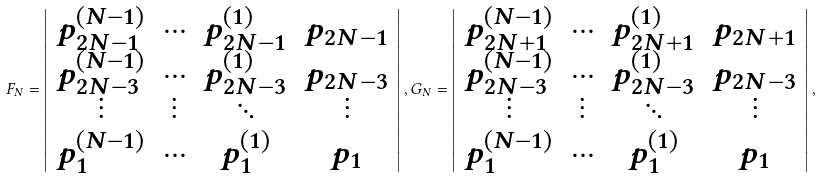Convert formula to latex. <formula><loc_0><loc_0><loc_500><loc_500>F _ { N } = \left | \begin{array} { c c c c } p _ { 2 N - 1 } ^ { ( N - 1 ) } & \cdots & p _ { 2 N - 1 } ^ { ( 1 ) } & p _ { 2 N - 1 } \\ p _ { 2 N - 3 } ^ { ( N - 1 ) } & \cdots & p _ { 2 N - 3 } ^ { ( 1 ) } & p _ { 2 N - 3 } \\ \vdots & \vdots & \ddots & \vdots \\ p _ { 1 } ^ { ( N - 1 ) } & \cdots & p _ { 1 } ^ { ( 1 ) } & p _ { 1 } \end{array} \right | , G _ { N } = \left | \begin{array} { c c c c } p _ { 2 N + 1 } ^ { ( N - 1 ) } & \cdots & p _ { 2 N + 1 } ^ { ( 1 ) } & p _ { 2 N + 1 } \\ p _ { 2 N - 3 } ^ { ( N - 1 ) } & \cdots & p _ { 2 N - 3 } ^ { ( 1 ) } & p _ { 2 N - 3 } \\ \vdots & \vdots & \ddots & \vdots \\ p _ { 1 } ^ { ( N - 1 ) } & \cdots & p _ { 1 } ^ { ( 1 ) } & p _ { 1 } \end{array} \right | ,</formula> 